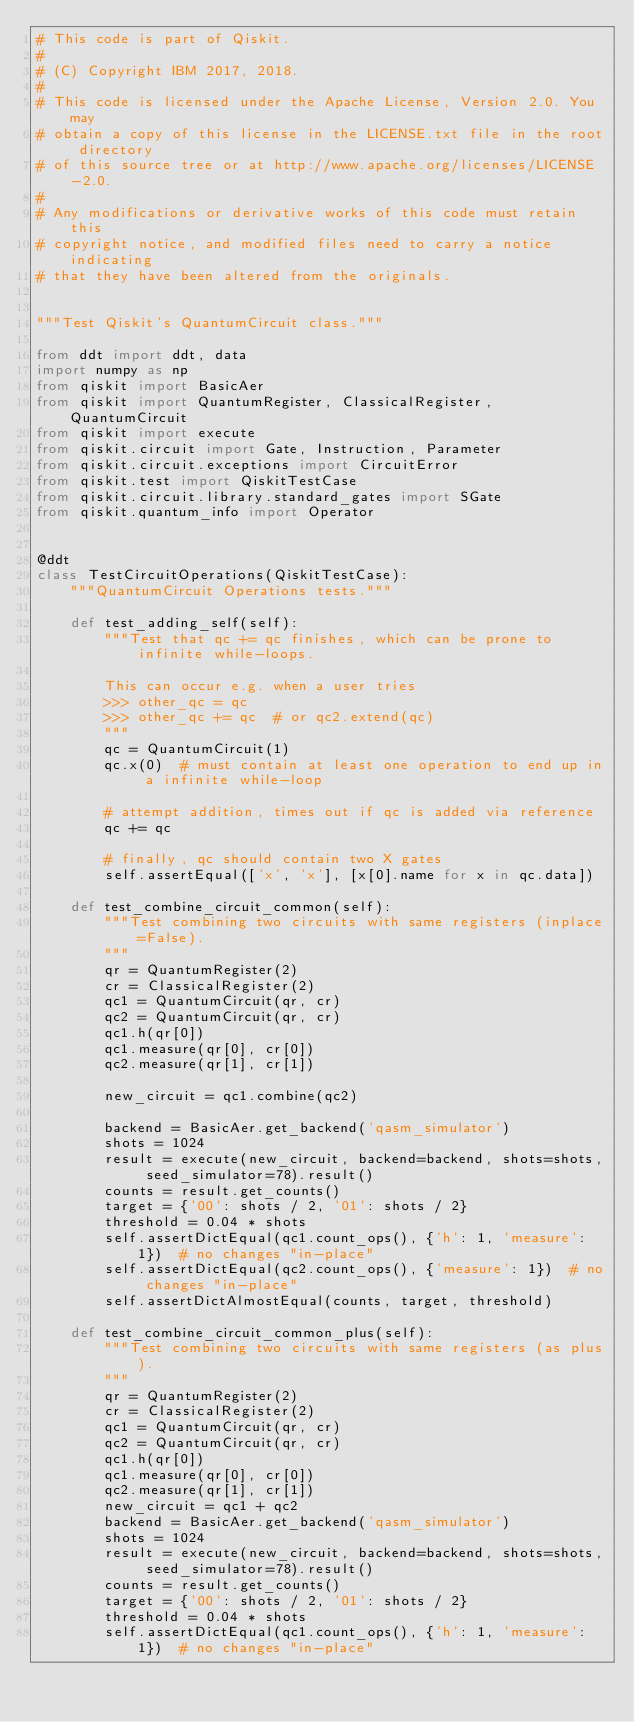Convert code to text. <code><loc_0><loc_0><loc_500><loc_500><_Python_># This code is part of Qiskit.
#
# (C) Copyright IBM 2017, 2018.
#
# This code is licensed under the Apache License, Version 2.0. You may
# obtain a copy of this license in the LICENSE.txt file in the root directory
# of this source tree or at http://www.apache.org/licenses/LICENSE-2.0.
#
# Any modifications or derivative works of this code must retain this
# copyright notice, and modified files need to carry a notice indicating
# that they have been altered from the originals.


"""Test Qiskit's QuantumCircuit class."""

from ddt import ddt, data
import numpy as np
from qiskit import BasicAer
from qiskit import QuantumRegister, ClassicalRegister, QuantumCircuit
from qiskit import execute
from qiskit.circuit import Gate, Instruction, Parameter
from qiskit.circuit.exceptions import CircuitError
from qiskit.test import QiskitTestCase
from qiskit.circuit.library.standard_gates import SGate
from qiskit.quantum_info import Operator


@ddt
class TestCircuitOperations(QiskitTestCase):
    """QuantumCircuit Operations tests."""

    def test_adding_self(self):
        """Test that qc += qc finishes, which can be prone to infinite while-loops.

        This can occur e.g. when a user tries
        >>> other_qc = qc
        >>> other_qc += qc  # or qc2.extend(qc)
        """
        qc = QuantumCircuit(1)
        qc.x(0)  # must contain at least one operation to end up in a infinite while-loop

        # attempt addition, times out if qc is added via reference
        qc += qc

        # finally, qc should contain two X gates
        self.assertEqual(['x', 'x'], [x[0].name for x in qc.data])

    def test_combine_circuit_common(self):
        """Test combining two circuits with same registers (inplace=False).
        """
        qr = QuantumRegister(2)
        cr = ClassicalRegister(2)
        qc1 = QuantumCircuit(qr, cr)
        qc2 = QuantumCircuit(qr, cr)
        qc1.h(qr[0])
        qc1.measure(qr[0], cr[0])
        qc2.measure(qr[1], cr[1])

        new_circuit = qc1.combine(qc2)

        backend = BasicAer.get_backend('qasm_simulator')
        shots = 1024
        result = execute(new_circuit, backend=backend, shots=shots, seed_simulator=78).result()
        counts = result.get_counts()
        target = {'00': shots / 2, '01': shots / 2}
        threshold = 0.04 * shots
        self.assertDictEqual(qc1.count_ops(), {'h': 1, 'measure': 1})  # no changes "in-place"
        self.assertDictEqual(qc2.count_ops(), {'measure': 1})  # no changes "in-place"
        self.assertDictAlmostEqual(counts, target, threshold)

    def test_combine_circuit_common_plus(self):
        """Test combining two circuits with same registers (as plus).
        """
        qr = QuantumRegister(2)
        cr = ClassicalRegister(2)
        qc1 = QuantumCircuit(qr, cr)
        qc2 = QuantumCircuit(qr, cr)
        qc1.h(qr[0])
        qc1.measure(qr[0], cr[0])
        qc2.measure(qr[1], cr[1])
        new_circuit = qc1 + qc2
        backend = BasicAer.get_backend('qasm_simulator')
        shots = 1024
        result = execute(new_circuit, backend=backend, shots=shots, seed_simulator=78).result()
        counts = result.get_counts()
        target = {'00': shots / 2, '01': shots / 2}
        threshold = 0.04 * shots
        self.assertDictEqual(qc1.count_ops(), {'h': 1, 'measure': 1})  # no changes "in-place"</code> 